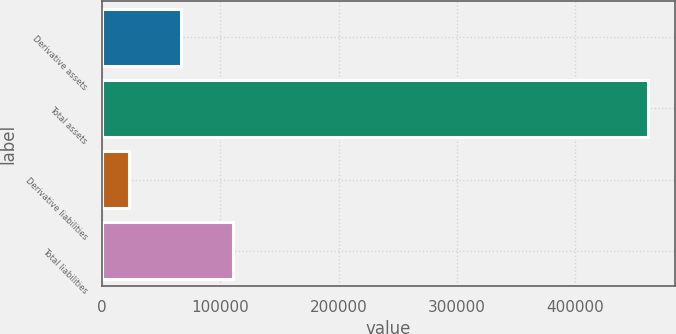Convert chart. <chart><loc_0><loc_0><loc_500><loc_500><bar_chart><fcel>Derivative assets<fcel>Total assets<fcel>Derivative liabilities<fcel>Total liabilities<nl><fcel>66317.2<fcel>461365<fcel>22423<fcel>110211<nl></chart> 